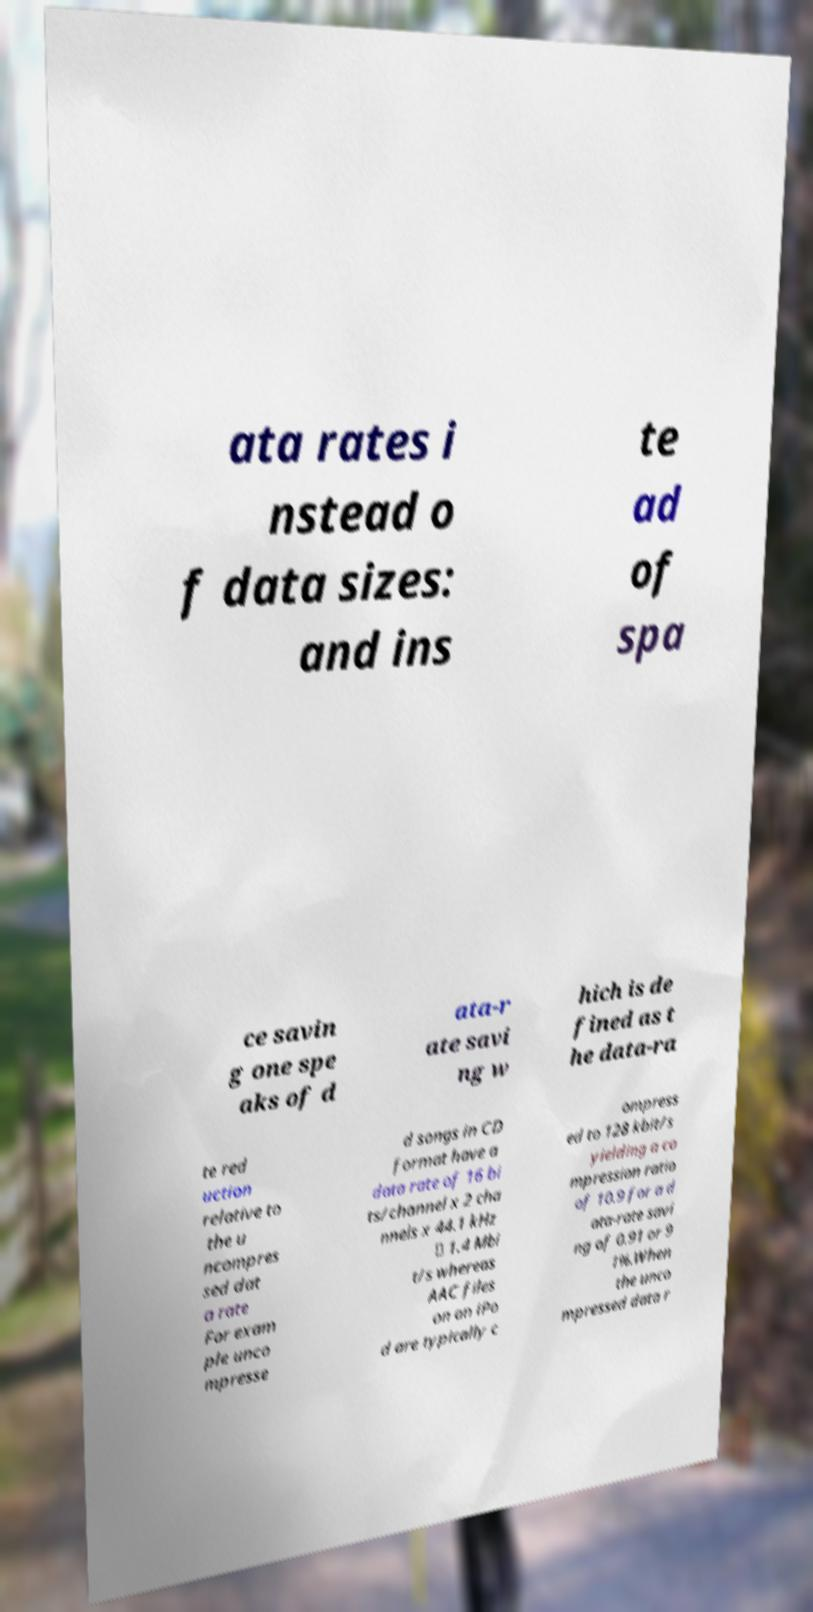What messages or text are displayed in this image? I need them in a readable, typed format. ata rates i nstead o f data sizes: and ins te ad of spa ce savin g one spe aks of d ata-r ate savi ng w hich is de fined as t he data-ra te red uction relative to the u ncompres sed dat a rate For exam ple unco mpresse d songs in CD format have a data rate of 16 bi ts/channel x 2 cha nnels x 44.1 kHz ≅ 1.4 Mbi t/s whereas AAC files on an iPo d are typically c ompress ed to 128 kbit/s yielding a co mpression ratio of 10.9 for a d ata-rate savi ng of 0.91 or 9 1%.When the unco mpressed data r 